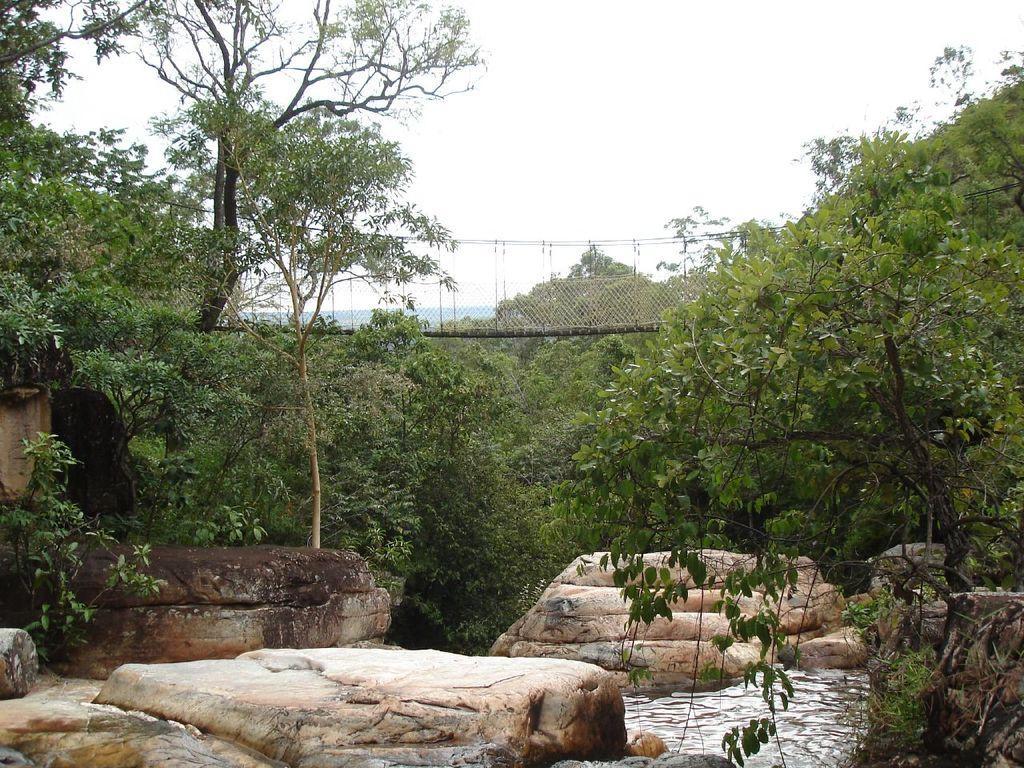Please provide a concise description of this image. In this image, there are a few stones, trees, plants. We can also see some water and a bridge. We can also see the sky. 